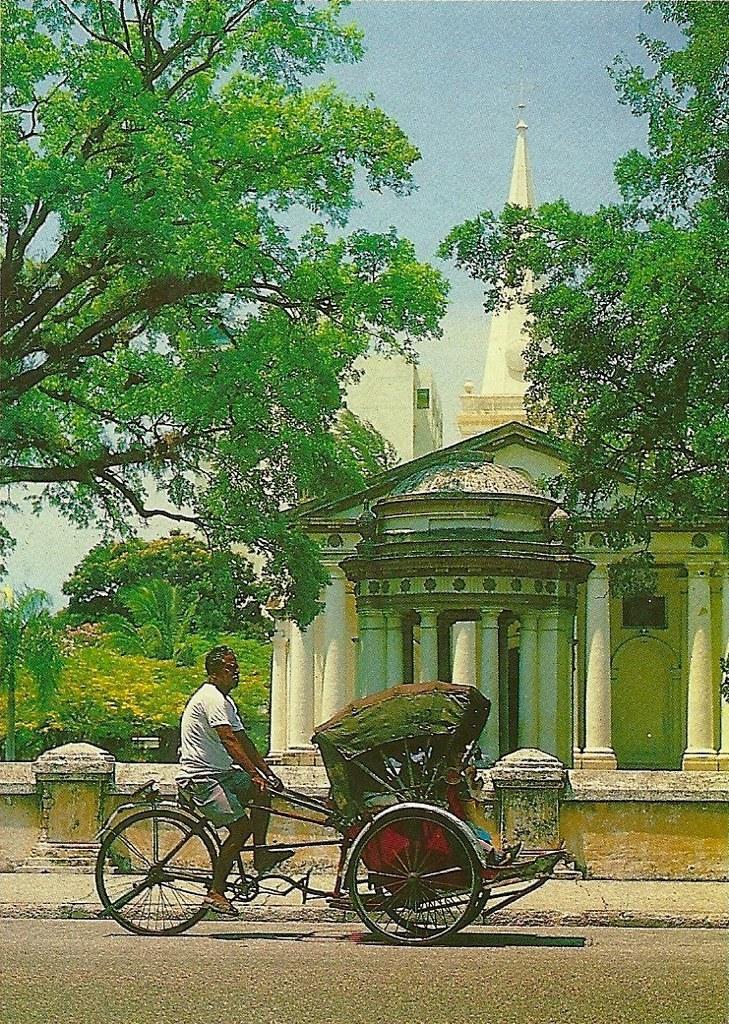How would you summarize this image in a sentence or two? In this image I can see a person riding a bicycle. To the side of him there is a building and trees. In the back there is a sky. 